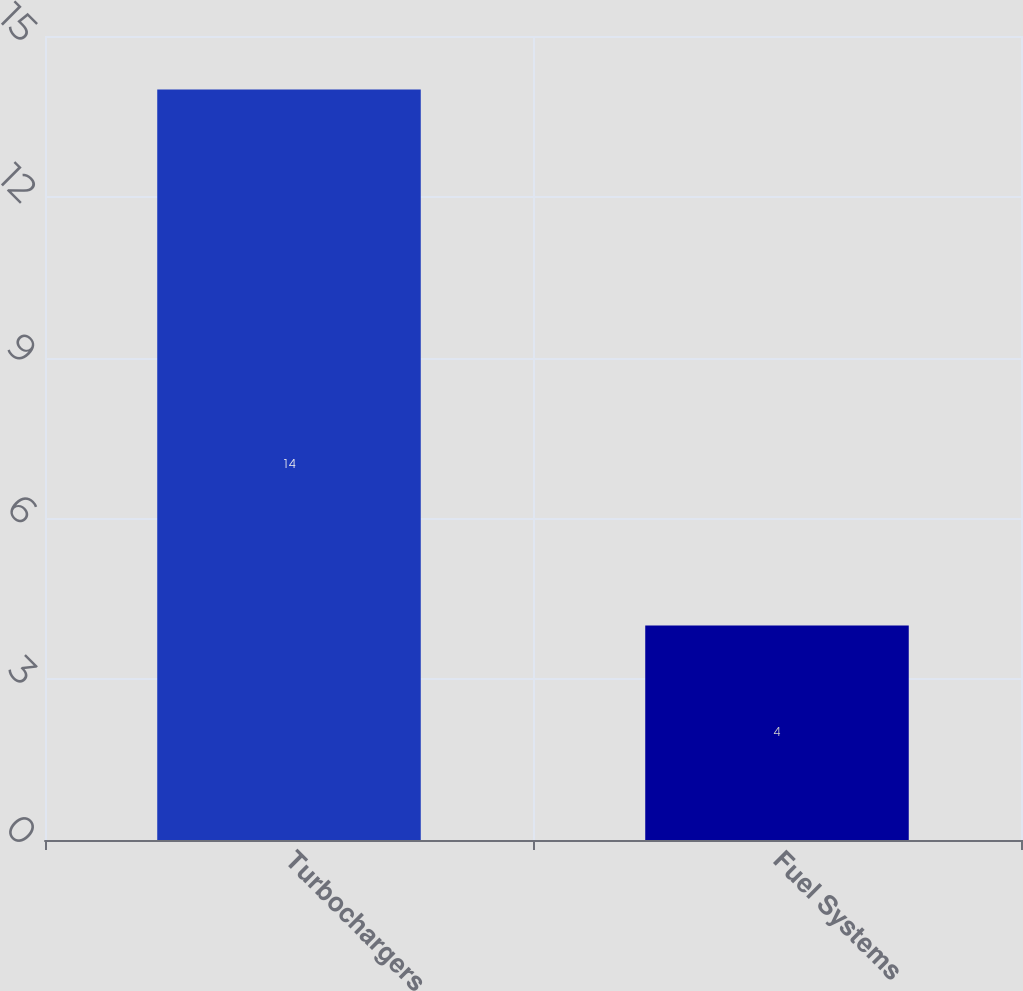Convert chart. <chart><loc_0><loc_0><loc_500><loc_500><bar_chart><fcel>Turbochargers<fcel>Fuel Systems<nl><fcel>14<fcel>4<nl></chart> 